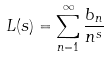<formula> <loc_0><loc_0><loc_500><loc_500>L ( s ) = \sum _ { n = 1 } ^ { \infty } \frac { b _ { n } } { n ^ { s } }</formula> 